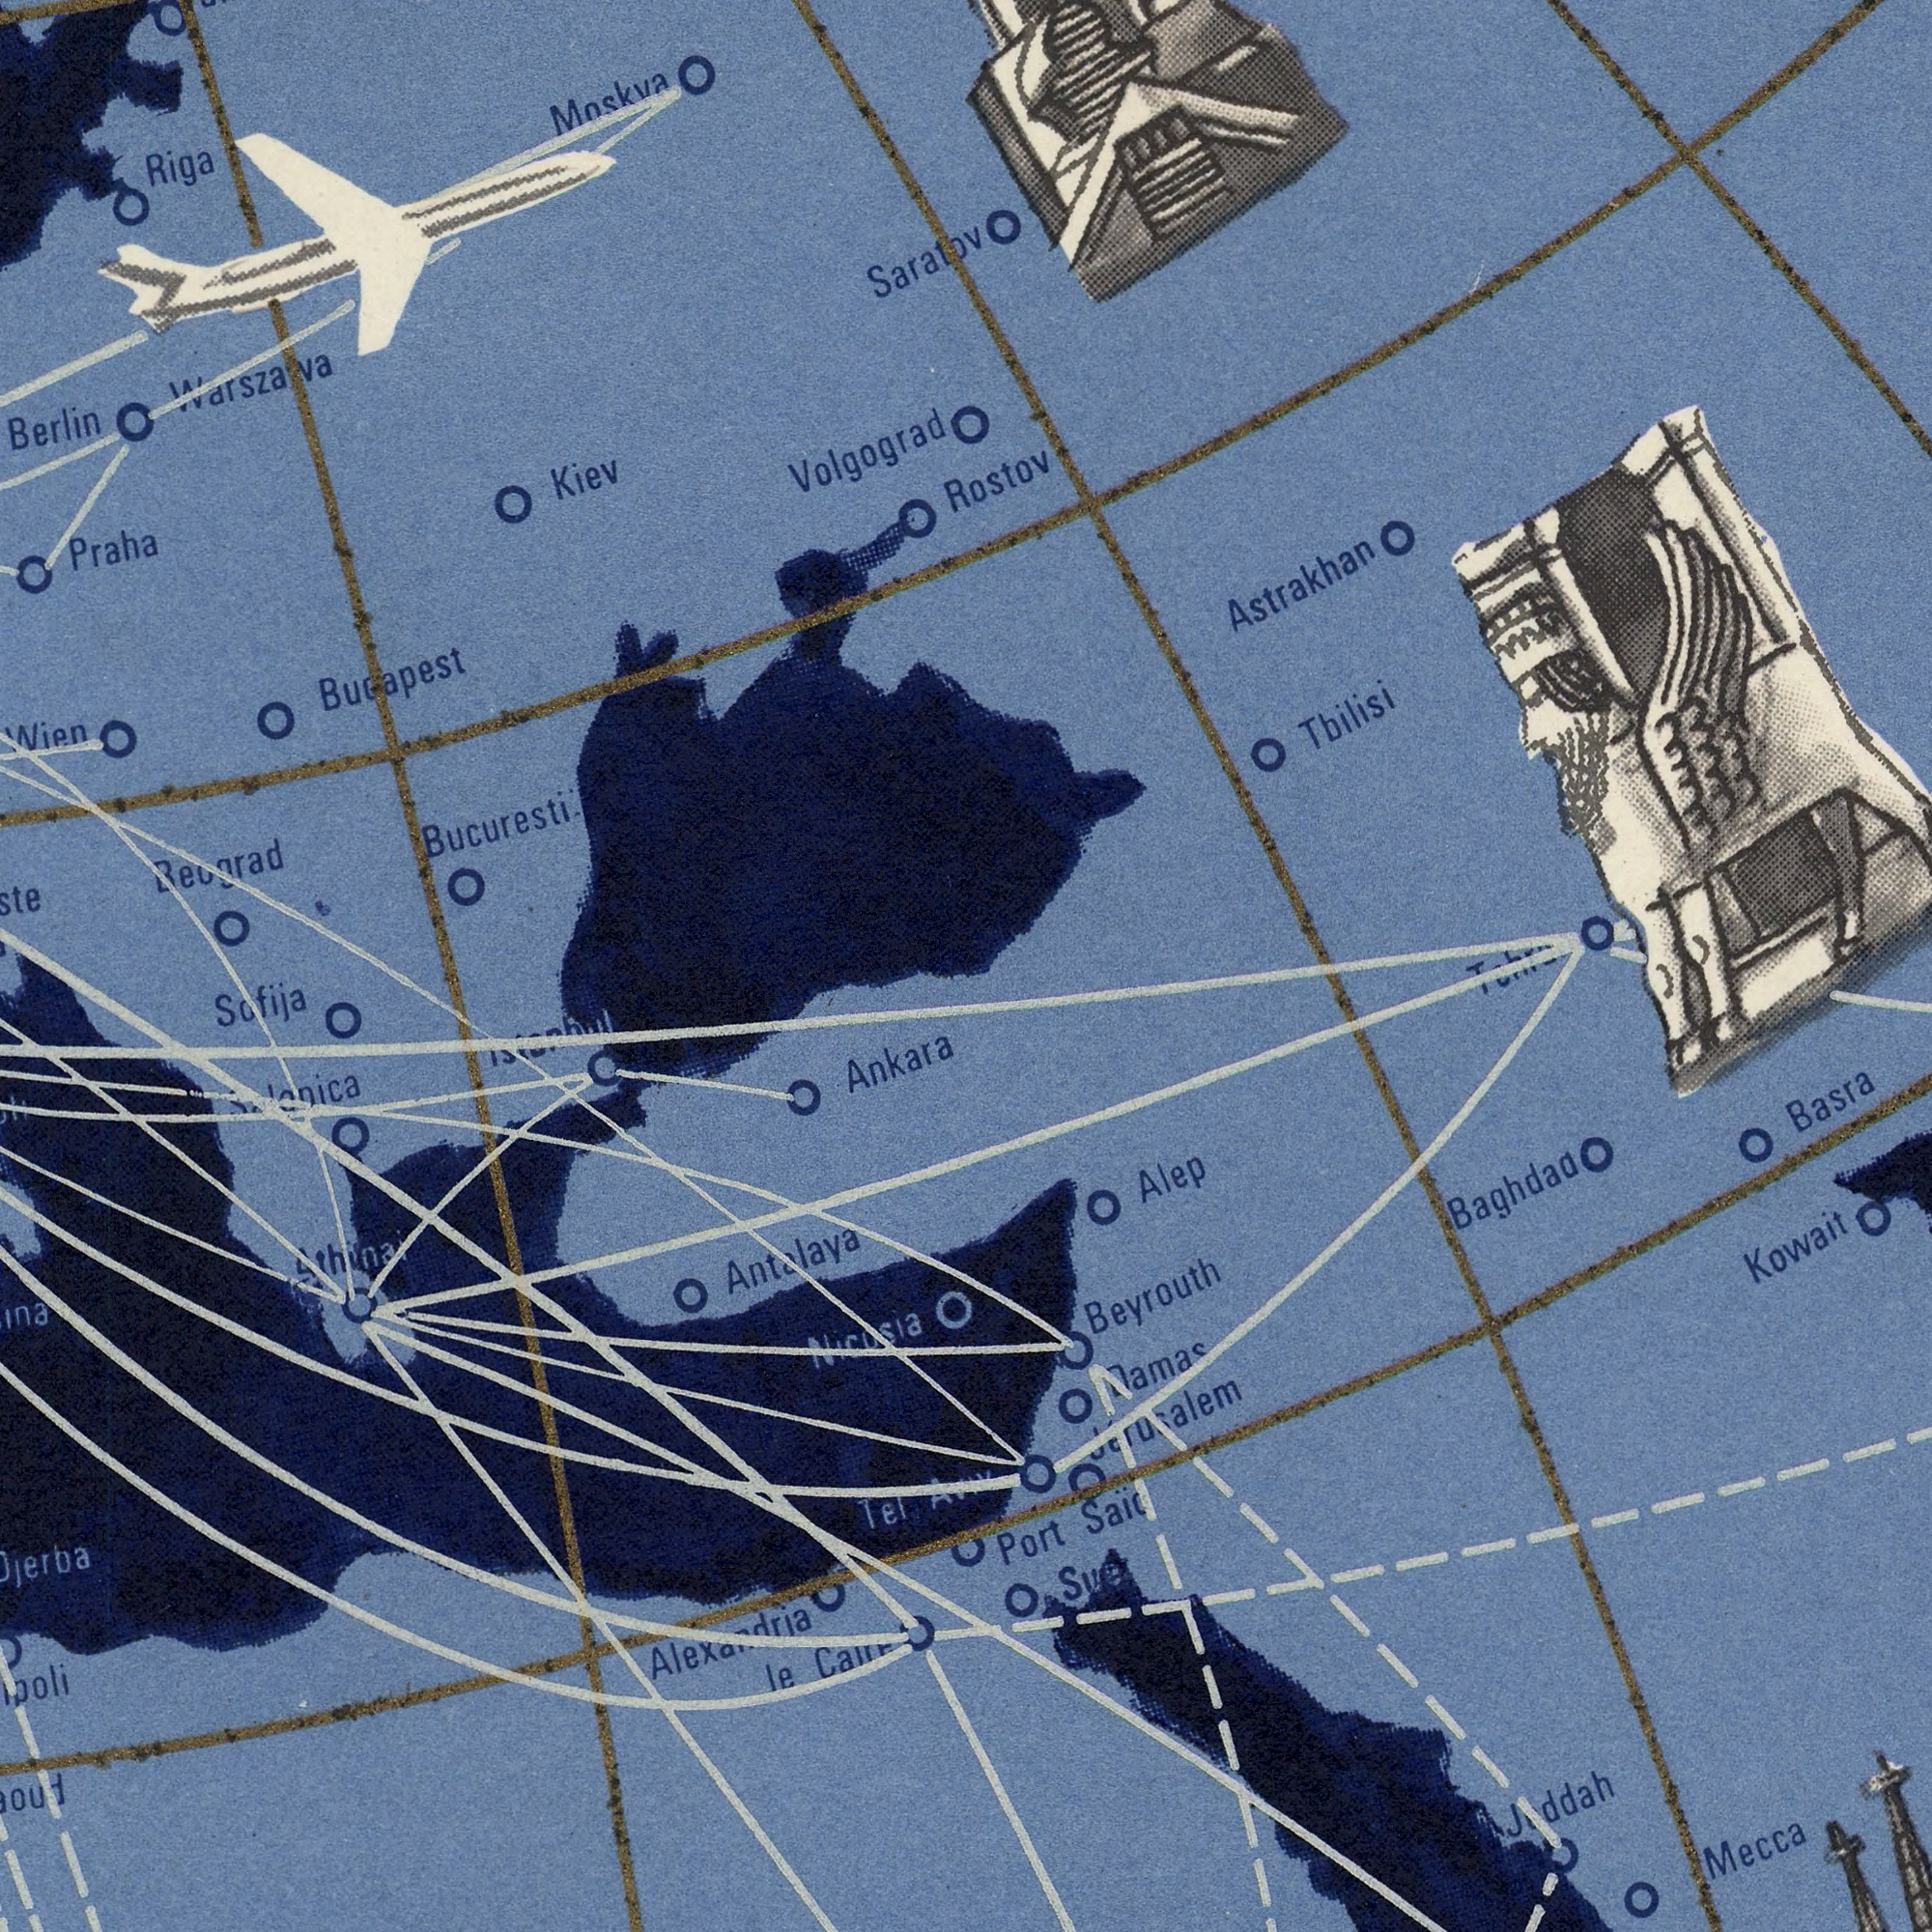What text can you see in the top-left section? Bucuresti Budapest Moskva Volgograd Praha Berlin Saratov Riga Kiev Beograd Warszawa Wien What text can you see in the bottom-right section? Basra Saїd Mecca Alep Baghdad Port Kowait Beyrouth Jerusalem Aviv What text can you see in the top-right section? Astrakhan Tbilisi Rostov What text can you see in the bottom-left section? Antalaya Ankara Sofija le Alexandria Tel ###nica Nicosia Athinai 